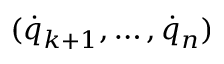<formula> <loc_0><loc_0><loc_500><loc_500>( { \dot { q } } _ { k + 1 } , \dots , { \dot { q } } _ { n } )</formula> 